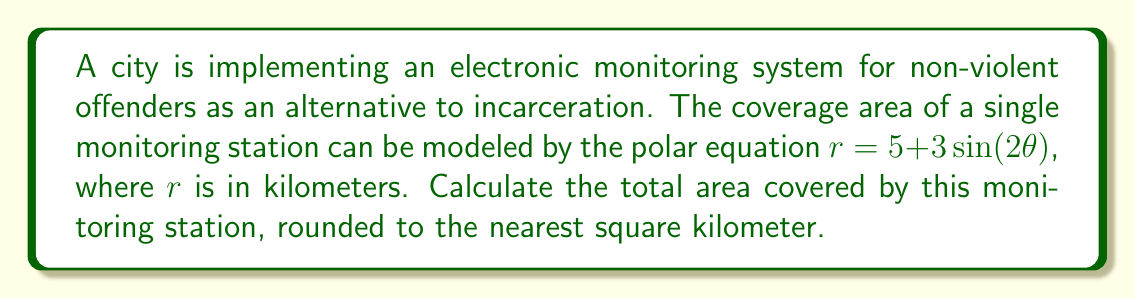Give your solution to this math problem. To solve this problem, we need to use the formula for the area enclosed by a polar curve. The formula is:

$$A = \frac{1}{2} \int_{0}^{2\pi} r^2 d\theta$$

Let's break this down step-by-step:

1) Our polar equation is $r = 5 + 3\sin(2\theta)$

2) We need to square this function:
   $r^2 = (5 + 3\sin(2\theta))^2 = 25 + 30\sin(2\theta) + 9\sin^2(2\theta)$

3) Now we can set up our integral:
   $$A = \frac{1}{2} \int_{0}^{2\pi} (25 + 30\sin(2\theta) + 9\sin^2(2\theta)) d\theta$$

4) Let's integrate each term separately:
   
   a) $\int_{0}^{2\pi} 25 d\theta = 25\theta |_{0}^{2\pi} = 50\pi$
   
   b) $\int_{0}^{2\pi} 30\sin(2\theta) d\theta = -15\cos(2\theta) |_{0}^{2\pi} = 0$
   
   c) $\int_{0}^{2\pi} 9\sin^2(2\theta) d\theta = \frac{9}{2}\theta - \frac{9}{4}\sin(4\theta) |_{0}^{2\pi} = 9\pi$

5) Adding these results:
   $$A = \frac{1}{2}(50\pi + 0 + 9\pi) = \frac{59\pi}{2} \approx 92.73 \text{ km}^2$$

6) Rounding to the nearest square kilometer:
   $93 \text{ km}^2$

This result provides the total area covered by a single monitoring station in the electronic monitoring system.
Answer: 93 km² 